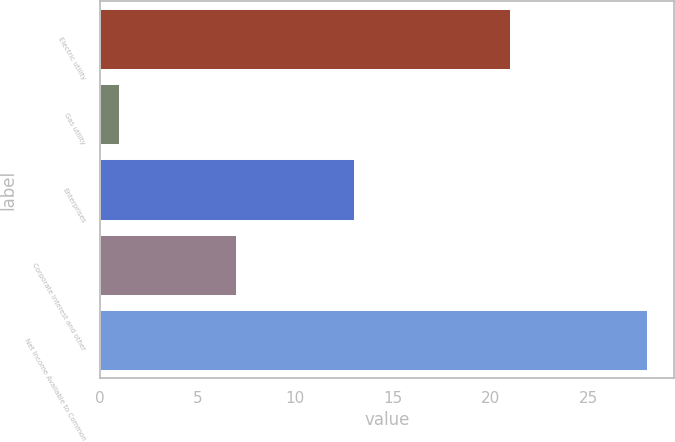<chart> <loc_0><loc_0><loc_500><loc_500><bar_chart><fcel>Electric utility<fcel>Gas utility<fcel>Enterprises<fcel>Corporate interest and other<fcel>Net Income Available to Common<nl><fcel>21<fcel>1<fcel>13<fcel>7<fcel>28<nl></chart> 